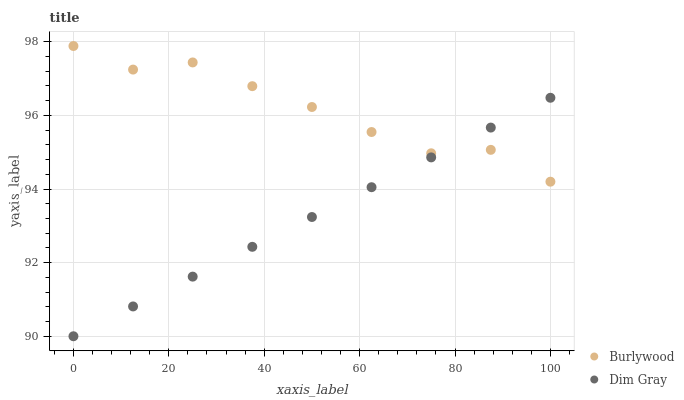Does Dim Gray have the minimum area under the curve?
Answer yes or no. Yes. Does Burlywood have the maximum area under the curve?
Answer yes or no. Yes. Does Dim Gray have the maximum area under the curve?
Answer yes or no. No. Is Dim Gray the smoothest?
Answer yes or no. Yes. Is Burlywood the roughest?
Answer yes or no. Yes. Is Dim Gray the roughest?
Answer yes or no. No. Does Dim Gray have the lowest value?
Answer yes or no. Yes. Does Burlywood have the highest value?
Answer yes or no. Yes. Does Dim Gray have the highest value?
Answer yes or no. No. Does Burlywood intersect Dim Gray?
Answer yes or no. Yes. Is Burlywood less than Dim Gray?
Answer yes or no. No. Is Burlywood greater than Dim Gray?
Answer yes or no. No. 